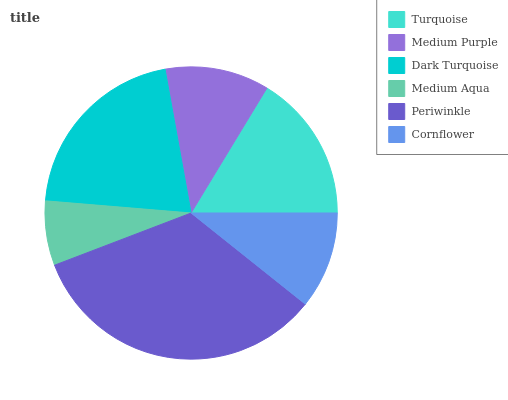Is Medium Aqua the minimum?
Answer yes or no. Yes. Is Periwinkle the maximum?
Answer yes or no. Yes. Is Medium Purple the minimum?
Answer yes or no. No. Is Medium Purple the maximum?
Answer yes or no. No. Is Turquoise greater than Medium Purple?
Answer yes or no. Yes. Is Medium Purple less than Turquoise?
Answer yes or no. Yes. Is Medium Purple greater than Turquoise?
Answer yes or no. No. Is Turquoise less than Medium Purple?
Answer yes or no. No. Is Turquoise the high median?
Answer yes or no. Yes. Is Medium Purple the low median?
Answer yes or no. Yes. Is Periwinkle the high median?
Answer yes or no. No. Is Periwinkle the low median?
Answer yes or no. No. 